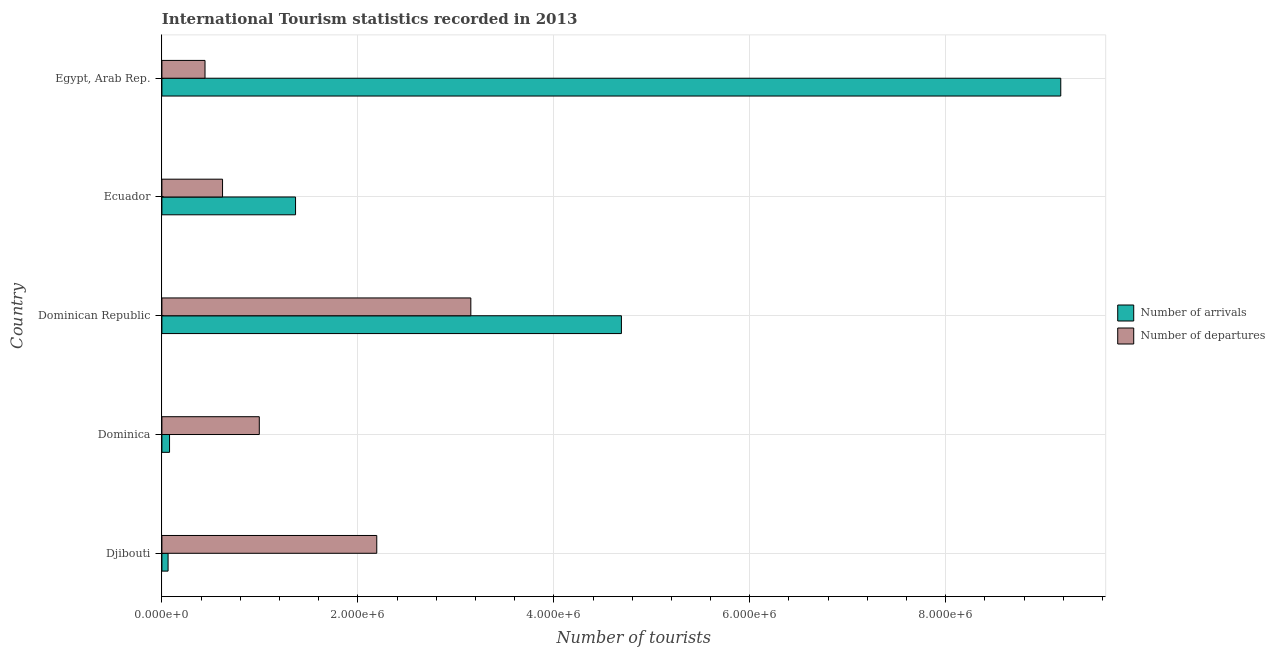How many different coloured bars are there?
Your answer should be compact. 2. Are the number of bars per tick equal to the number of legend labels?
Keep it short and to the point. Yes. How many bars are there on the 3rd tick from the top?
Give a very brief answer. 2. How many bars are there on the 5th tick from the bottom?
Ensure brevity in your answer.  2. What is the label of the 4th group of bars from the top?
Provide a short and direct response. Dominica. In how many cases, is the number of bars for a given country not equal to the number of legend labels?
Offer a terse response. 0. What is the number of tourist departures in Djibouti?
Your answer should be compact. 2.19e+06. Across all countries, what is the maximum number of tourist arrivals?
Offer a terse response. 9.17e+06. In which country was the number of tourist arrivals maximum?
Offer a very short reply. Egypt, Arab Rep. In which country was the number of tourist departures minimum?
Offer a very short reply. Egypt, Arab Rep. What is the total number of tourist departures in the graph?
Give a very brief answer. 7.40e+06. What is the difference between the number of tourist arrivals in Dominica and that in Ecuador?
Provide a succinct answer. -1.29e+06. What is the difference between the number of tourist departures in Ecuador and the number of tourist arrivals in Egypt, Arab Rep.?
Give a very brief answer. -8.56e+06. What is the average number of tourist arrivals per country?
Offer a very short reply. 3.07e+06. What is the difference between the number of tourist arrivals and number of tourist departures in Egypt, Arab Rep.?
Provide a short and direct response. 8.73e+06. In how many countries, is the number of tourist arrivals greater than 6000000 ?
Your answer should be compact. 1. What is the ratio of the number of tourist arrivals in Dominica to that in Ecuador?
Ensure brevity in your answer.  0.06. Is the difference between the number of tourist arrivals in Djibouti and Ecuador greater than the difference between the number of tourist departures in Djibouti and Ecuador?
Make the answer very short. No. What is the difference between the highest and the second highest number of tourist departures?
Give a very brief answer. 9.60e+05. What is the difference between the highest and the lowest number of tourist departures?
Keep it short and to the point. 2.71e+06. What does the 1st bar from the top in Djibouti represents?
Your answer should be very brief. Number of departures. What does the 1st bar from the bottom in Dominica represents?
Provide a succinct answer. Number of arrivals. How many bars are there?
Your answer should be very brief. 10. Are all the bars in the graph horizontal?
Offer a very short reply. Yes. Does the graph contain any zero values?
Provide a succinct answer. No. Does the graph contain grids?
Make the answer very short. Yes. Where does the legend appear in the graph?
Your answer should be compact. Center right. What is the title of the graph?
Make the answer very short. International Tourism statistics recorded in 2013. What is the label or title of the X-axis?
Offer a very short reply. Number of tourists. What is the label or title of the Y-axis?
Ensure brevity in your answer.  Country. What is the Number of tourists in Number of arrivals in Djibouti?
Your answer should be very brief. 6.30e+04. What is the Number of tourists in Number of departures in Djibouti?
Ensure brevity in your answer.  2.19e+06. What is the Number of tourists of Number of arrivals in Dominica?
Your answer should be very brief. 7.80e+04. What is the Number of tourists in Number of departures in Dominica?
Your answer should be very brief. 9.94e+05. What is the Number of tourists in Number of arrivals in Dominican Republic?
Provide a succinct answer. 4.69e+06. What is the Number of tourists of Number of departures in Dominican Republic?
Your response must be concise. 3.15e+06. What is the Number of tourists in Number of arrivals in Ecuador?
Your response must be concise. 1.36e+06. What is the Number of tourists in Number of departures in Ecuador?
Keep it short and to the point. 6.19e+05. What is the Number of tourists of Number of arrivals in Egypt, Arab Rep.?
Ensure brevity in your answer.  9.17e+06. What is the Number of tourists in Number of departures in Egypt, Arab Rep.?
Offer a very short reply. 4.40e+05. Across all countries, what is the maximum Number of tourists in Number of arrivals?
Provide a succinct answer. 9.17e+06. Across all countries, what is the maximum Number of tourists in Number of departures?
Offer a very short reply. 3.15e+06. Across all countries, what is the minimum Number of tourists of Number of arrivals?
Ensure brevity in your answer.  6.30e+04. Across all countries, what is the minimum Number of tourists in Number of departures?
Give a very brief answer. 4.40e+05. What is the total Number of tourists in Number of arrivals in the graph?
Keep it short and to the point. 1.54e+07. What is the total Number of tourists of Number of departures in the graph?
Make the answer very short. 7.40e+06. What is the difference between the Number of tourists of Number of arrivals in Djibouti and that in Dominica?
Provide a short and direct response. -1.50e+04. What is the difference between the Number of tourists in Number of departures in Djibouti and that in Dominica?
Offer a very short reply. 1.20e+06. What is the difference between the Number of tourists of Number of arrivals in Djibouti and that in Dominican Republic?
Your answer should be compact. -4.63e+06. What is the difference between the Number of tourists of Number of departures in Djibouti and that in Dominican Republic?
Your answer should be compact. -9.60e+05. What is the difference between the Number of tourists in Number of arrivals in Djibouti and that in Ecuador?
Your answer should be compact. -1.30e+06. What is the difference between the Number of tourists in Number of departures in Djibouti and that in Ecuador?
Your response must be concise. 1.57e+06. What is the difference between the Number of tourists of Number of arrivals in Djibouti and that in Egypt, Arab Rep.?
Your answer should be compact. -9.11e+06. What is the difference between the Number of tourists of Number of departures in Djibouti and that in Egypt, Arab Rep.?
Your response must be concise. 1.75e+06. What is the difference between the Number of tourists in Number of arrivals in Dominica and that in Dominican Republic?
Provide a short and direct response. -4.61e+06. What is the difference between the Number of tourists of Number of departures in Dominica and that in Dominican Republic?
Ensure brevity in your answer.  -2.16e+06. What is the difference between the Number of tourists of Number of arrivals in Dominica and that in Ecuador?
Make the answer very short. -1.29e+06. What is the difference between the Number of tourists of Number of departures in Dominica and that in Ecuador?
Provide a succinct answer. 3.75e+05. What is the difference between the Number of tourists of Number of arrivals in Dominica and that in Egypt, Arab Rep.?
Your answer should be very brief. -9.10e+06. What is the difference between the Number of tourists of Number of departures in Dominica and that in Egypt, Arab Rep.?
Provide a succinct answer. 5.54e+05. What is the difference between the Number of tourists in Number of arrivals in Dominican Republic and that in Ecuador?
Ensure brevity in your answer.  3.33e+06. What is the difference between the Number of tourists in Number of departures in Dominican Republic and that in Ecuador?
Provide a succinct answer. 2.53e+06. What is the difference between the Number of tourists of Number of arrivals in Dominican Republic and that in Egypt, Arab Rep.?
Your answer should be compact. -4.48e+06. What is the difference between the Number of tourists of Number of departures in Dominican Republic and that in Egypt, Arab Rep.?
Your answer should be compact. 2.71e+06. What is the difference between the Number of tourists of Number of arrivals in Ecuador and that in Egypt, Arab Rep.?
Offer a terse response. -7.81e+06. What is the difference between the Number of tourists of Number of departures in Ecuador and that in Egypt, Arab Rep.?
Ensure brevity in your answer.  1.79e+05. What is the difference between the Number of tourists in Number of arrivals in Djibouti and the Number of tourists in Number of departures in Dominica?
Provide a short and direct response. -9.31e+05. What is the difference between the Number of tourists in Number of arrivals in Djibouti and the Number of tourists in Number of departures in Dominican Republic?
Give a very brief answer. -3.09e+06. What is the difference between the Number of tourists of Number of arrivals in Djibouti and the Number of tourists of Number of departures in Ecuador?
Provide a short and direct response. -5.56e+05. What is the difference between the Number of tourists of Number of arrivals in Djibouti and the Number of tourists of Number of departures in Egypt, Arab Rep.?
Your answer should be compact. -3.77e+05. What is the difference between the Number of tourists in Number of arrivals in Dominica and the Number of tourists in Number of departures in Dominican Republic?
Offer a terse response. -3.08e+06. What is the difference between the Number of tourists of Number of arrivals in Dominica and the Number of tourists of Number of departures in Ecuador?
Offer a very short reply. -5.41e+05. What is the difference between the Number of tourists in Number of arrivals in Dominica and the Number of tourists in Number of departures in Egypt, Arab Rep.?
Your response must be concise. -3.62e+05. What is the difference between the Number of tourists of Number of arrivals in Dominican Republic and the Number of tourists of Number of departures in Ecuador?
Make the answer very short. 4.07e+06. What is the difference between the Number of tourists in Number of arrivals in Dominican Republic and the Number of tourists in Number of departures in Egypt, Arab Rep.?
Make the answer very short. 4.25e+06. What is the difference between the Number of tourists of Number of arrivals in Ecuador and the Number of tourists of Number of departures in Egypt, Arab Rep.?
Offer a very short reply. 9.24e+05. What is the average Number of tourists of Number of arrivals per country?
Make the answer very short. 3.07e+06. What is the average Number of tourists of Number of departures per country?
Your response must be concise. 1.48e+06. What is the difference between the Number of tourists of Number of arrivals and Number of tourists of Number of departures in Djibouti?
Your answer should be compact. -2.13e+06. What is the difference between the Number of tourists of Number of arrivals and Number of tourists of Number of departures in Dominica?
Ensure brevity in your answer.  -9.16e+05. What is the difference between the Number of tourists of Number of arrivals and Number of tourists of Number of departures in Dominican Republic?
Offer a terse response. 1.54e+06. What is the difference between the Number of tourists in Number of arrivals and Number of tourists in Number of departures in Ecuador?
Your response must be concise. 7.45e+05. What is the difference between the Number of tourists of Number of arrivals and Number of tourists of Number of departures in Egypt, Arab Rep.?
Keep it short and to the point. 8.73e+06. What is the ratio of the Number of tourists of Number of arrivals in Djibouti to that in Dominica?
Ensure brevity in your answer.  0.81. What is the ratio of the Number of tourists of Number of departures in Djibouti to that in Dominica?
Offer a very short reply. 2.21. What is the ratio of the Number of tourists in Number of arrivals in Djibouti to that in Dominican Republic?
Your answer should be very brief. 0.01. What is the ratio of the Number of tourists in Number of departures in Djibouti to that in Dominican Republic?
Provide a short and direct response. 0.7. What is the ratio of the Number of tourists of Number of arrivals in Djibouti to that in Ecuador?
Offer a terse response. 0.05. What is the ratio of the Number of tourists of Number of departures in Djibouti to that in Ecuador?
Your answer should be very brief. 3.54. What is the ratio of the Number of tourists in Number of arrivals in Djibouti to that in Egypt, Arab Rep.?
Provide a succinct answer. 0.01. What is the ratio of the Number of tourists of Number of departures in Djibouti to that in Egypt, Arab Rep.?
Offer a very short reply. 4.98. What is the ratio of the Number of tourists in Number of arrivals in Dominica to that in Dominican Republic?
Make the answer very short. 0.02. What is the ratio of the Number of tourists in Number of departures in Dominica to that in Dominican Republic?
Provide a succinct answer. 0.32. What is the ratio of the Number of tourists in Number of arrivals in Dominica to that in Ecuador?
Provide a succinct answer. 0.06. What is the ratio of the Number of tourists of Number of departures in Dominica to that in Ecuador?
Make the answer very short. 1.61. What is the ratio of the Number of tourists in Number of arrivals in Dominica to that in Egypt, Arab Rep.?
Ensure brevity in your answer.  0.01. What is the ratio of the Number of tourists in Number of departures in Dominica to that in Egypt, Arab Rep.?
Your response must be concise. 2.26. What is the ratio of the Number of tourists in Number of arrivals in Dominican Republic to that in Ecuador?
Your answer should be very brief. 3.44. What is the ratio of the Number of tourists in Number of departures in Dominican Republic to that in Ecuador?
Your answer should be compact. 5.09. What is the ratio of the Number of tourists in Number of arrivals in Dominican Republic to that in Egypt, Arab Rep.?
Give a very brief answer. 0.51. What is the ratio of the Number of tourists in Number of departures in Dominican Republic to that in Egypt, Arab Rep.?
Your answer should be compact. 7.17. What is the ratio of the Number of tourists in Number of arrivals in Ecuador to that in Egypt, Arab Rep.?
Your answer should be very brief. 0.15. What is the ratio of the Number of tourists of Number of departures in Ecuador to that in Egypt, Arab Rep.?
Provide a succinct answer. 1.41. What is the difference between the highest and the second highest Number of tourists in Number of arrivals?
Give a very brief answer. 4.48e+06. What is the difference between the highest and the second highest Number of tourists of Number of departures?
Offer a very short reply. 9.60e+05. What is the difference between the highest and the lowest Number of tourists of Number of arrivals?
Offer a terse response. 9.11e+06. What is the difference between the highest and the lowest Number of tourists of Number of departures?
Provide a short and direct response. 2.71e+06. 